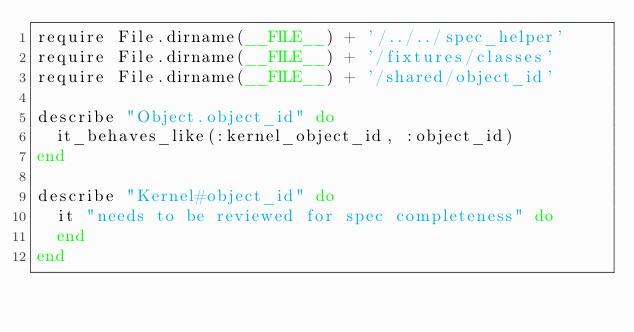Convert code to text. <code><loc_0><loc_0><loc_500><loc_500><_Ruby_>require File.dirname(__FILE__) + '/../../spec_helper'
require File.dirname(__FILE__) + '/fixtures/classes'
require File.dirname(__FILE__) + '/shared/object_id'

describe "Object.object_id" do
  it_behaves_like(:kernel_object_id, :object_id) 
end

describe "Kernel#object_id" do
  it "needs to be reviewed for spec completeness" do
  end
end
</code> 